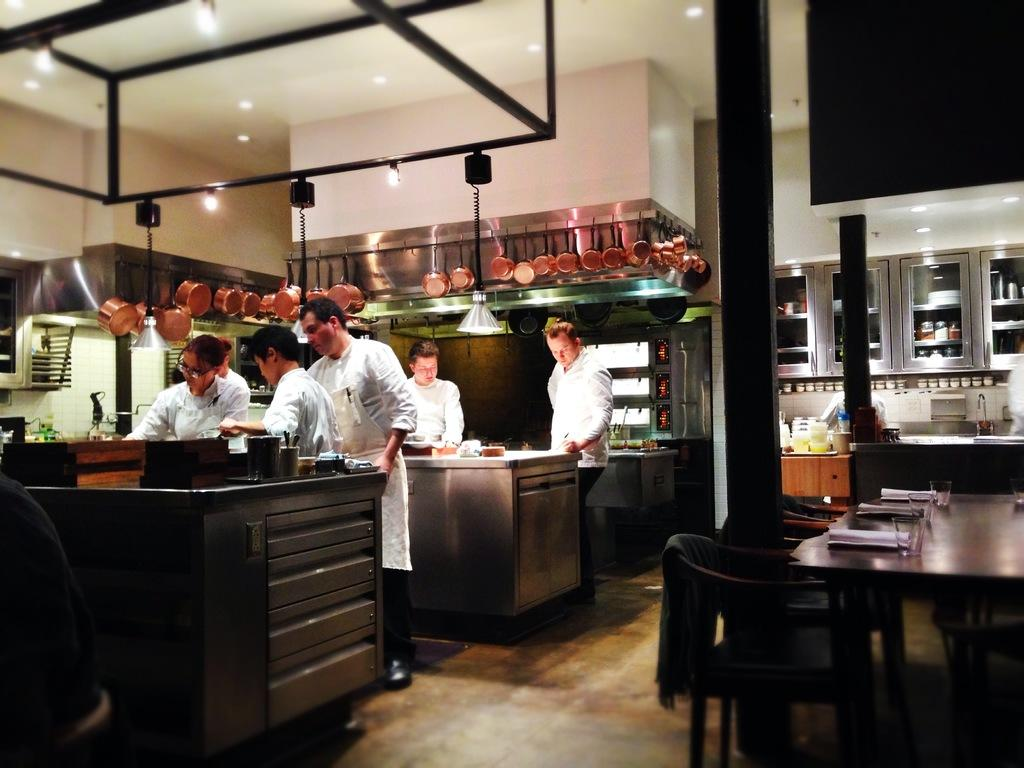How many people are in total can be seen in the image? There are five persons in the image. What are the persons doing in the image? The persons are working in the kitchen. What type of table is in the image? There is a wooden table in the image. What is on the table in the image? A glass and papers are on the table. What type of substance is being used by the persons to clean the kitchen? There is no indication of a cleaning substance being used in the image. Can you see any pears on the table in the image? There are no pears present on the table in the image. 